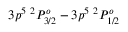Convert formula to latex. <formula><loc_0><loc_0><loc_500><loc_500>3 p ^ { 5 2 } P _ { 3 / 2 } ^ { o } - 3 p ^ { 5 2 } P _ { 1 / 2 } ^ { o }</formula> 